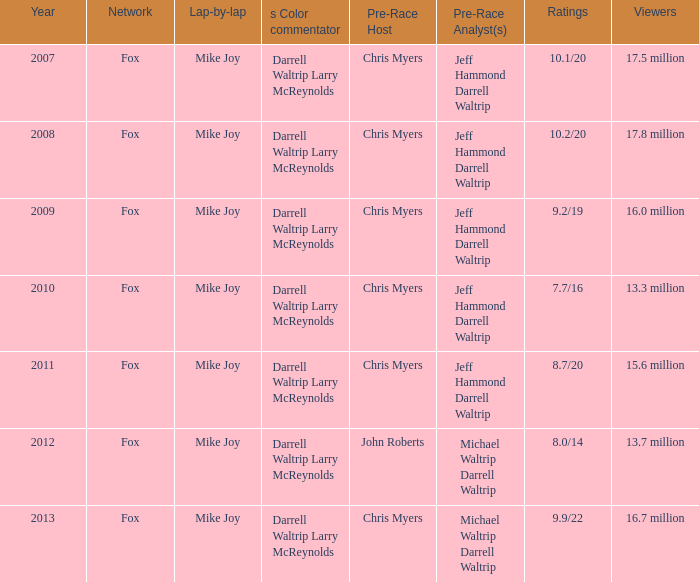How many scores did the 2013 year have? 9.9/22. 